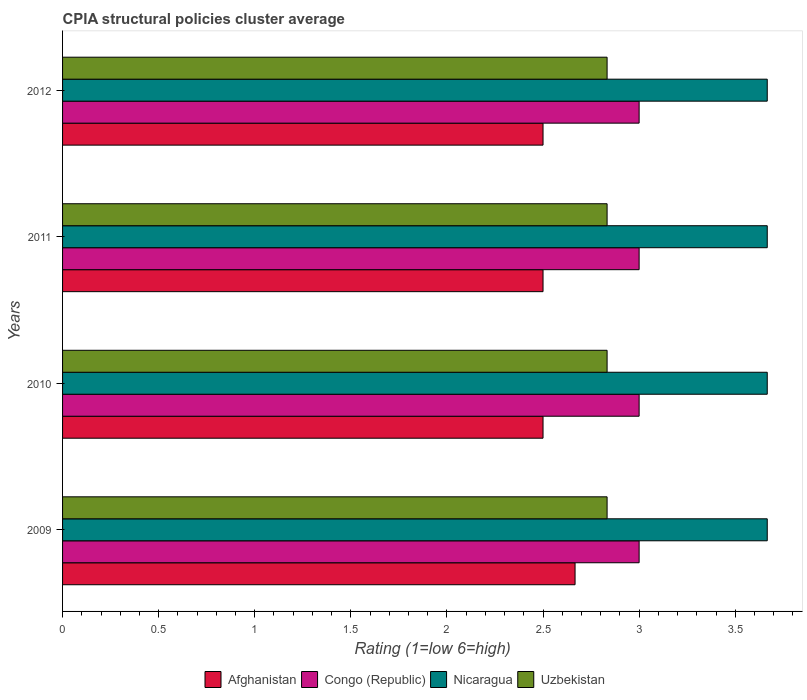How many different coloured bars are there?
Ensure brevity in your answer.  4. How many groups of bars are there?
Provide a succinct answer. 4. Are the number of bars on each tick of the Y-axis equal?
Provide a succinct answer. Yes. What is the CPIA rating in Uzbekistan in 2012?
Offer a very short reply. 2.83. Across all years, what is the maximum CPIA rating in Uzbekistan?
Give a very brief answer. 2.83. Across all years, what is the minimum CPIA rating in Congo (Republic)?
Give a very brief answer. 3. In which year was the CPIA rating in Afghanistan maximum?
Your answer should be very brief. 2009. What is the total CPIA rating in Uzbekistan in the graph?
Your response must be concise. 11.33. What is the difference between the CPIA rating in Nicaragua in 2010 and the CPIA rating in Congo (Republic) in 2012?
Provide a short and direct response. 0.67. What is the average CPIA rating in Afghanistan per year?
Your response must be concise. 2.54. In the year 2009, what is the difference between the CPIA rating in Afghanistan and CPIA rating in Congo (Republic)?
Offer a terse response. -0.33. What is the ratio of the CPIA rating in Nicaragua in 2009 to that in 2011?
Your response must be concise. 1. Is the CPIA rating in Congo (Republic) in 2010 less than that in 2011?
Your answer should be very brief. No. Is the difference between the CPIA rating in Afghanistan in 2010 and 2012 greater than the difference between the CPIA rating in Congo (Republic) in 2010 and 2012?
Keep it short and to the point. No. What is the difference between the highest and the second highest CPIA rating in Uzbekistan?
Provide a succinct answer. 0. In how many years, is the CPIA rating in Nicaragua greater than the average CPIA rating in Nicaragua taken over all years?
Give a very brief answer. 0. Is it the case that in every year, the sum of the CPIA rating in Afghanistan and CPIA rating in Congo (Republic) is greater than the sum of CPIA rating in Nicaragua and CPIA rating in Uzbekistan?
Offer a terse response. No. What does the 3rd bar from the top in 2009 represents?
Provide a short and direct response. Congo (Republic). What does the 4th bar from the bottom in 2011 represents?
Ensure brevity in your answer.  Uzbekistan. Is it the case that in every year, the sum of the CPIA rating in Nicaragua and CPIA rating in Afghanistan is greater than the CPIA rating in Uzbekistan?
Offer a very short reply. Yes. How many bars are there?
Your answer should be compact. 16. How many years are there in the graph?
Your response must be concise. 4. Are the values on the major ticks of X-axis written in scientific E-notation?
Ensure brevity in your answer.  No. Does the graph contain grids?
Provide a succinct answer. No. How many legend labels are there?
Your answer should be compact. 4. How are the legend labels stacked?
Offer a very short reply. Horizontal. What is the title of the graph?
Provide a short and direct response. CPIA structural policies cluster average. Does "Bolivia" appear as one of the legend labels in the graph?
Offer a very short reply. No. What is the label or title of the X-axis?
Ensure brevity in your answer.  Rating (1=low 6=high). What is the Rating (1=low 6=high) in Afghanistan in 2009?
Provide a short and direct response. 2.67. What is the Rating (1=low 6=high) of Congo (Republic) in 2009?
Offer a terse response. 3. What is the Rating (1=low 6=high) of Nicaragua in 2009?
Provide a short and direct response. 3.67. What is the Rating (1=low 6=high) of Uzbekistan in 2009?
Your response must be concise. 2.83. What is the Rating (1=low 6=high) in Afghanistan in 2010?
Offer a very short reply. 2.5. What is the Rating (1=low 6=high) in Nicaragua in 2010?
Give a very brief answer. 3.67. What is the Rating (1=low 6=high) of Uzbekistan in 2010?
Provide a short and direct response. 2.83. What is the Rating (1=low 6=high) of Nicaragua in 2011?
Your response must be concise. 3.67. What is the Rating (1=low 6=high) of Uzbekistan in 2011?
Your response must be concise. 2.83. What is the Rating (1=low 6=high) in Afghanistan in 2012?
Your response must be concise. 2.5. What is the Rating (1=low 6=high) in Congo (Republic) in 2012?
Offer a very short reply. 3. What is the Rating (1=low 6=high) in Nicaragua in 2012?
Offer a terse response. 3.67. What is the Rating (1=low 6=high) in Uzbekistan in 2012?
Provide a short and direct response. 2.83. Across all years, what is the maximum Rating (1=low 6=high) of Afghanistan?
Provide a short and direct response. 2.67. Across all years, what is the maximum Rating (1=low 6=high) of Nicaragua?
Offer a terse response. 3.67. Across all years, what is the maximum Rating (1=low 6=high) of Uzbekistan?
Offer a terse response. 2.83. Across all years, what is the minimum Rating (1=low 6=high) in Afghanistan?
Keep it short and to the point. 2.5. Across all years, what is the minimum Rating (1=low 6=high) of Congo (Republic)?
Give a very brief answer. 3. Across all years, what is the minimum Rating (1=low 6=high) in Nicaragua?
Provide a succinct answer. 3.67. Across all years, what is the minimum Rating (1=low 6=high) in Uzbekistan?
Your response must be concise. 2.83. What is the total Rating (1=low 6=high) in Afghanistan in the graph?
Offer a terse response. 10.17. What is the total Rating (1=low 6=high) in Nicaragua in the graph?
Give a very brief answer. 14.67. What is the total Rating (1=low 6=high) of Uzbekistan in the graph?
Your response must be concise. 11.33. What is the difference between the Rating (1=low 6=high) in Nicaragua in 2009 and that in 2010?
Make the answer very short. 0. What is the difference between the Rating (1=low 6=high) in Uzbekistan in 2009 and that in 2010?
Ensure brevity in your answer.  0. What is the difference between the Rating (1=low 6=high) in Afghanistan in 2009 and that in 2011?
Make the answer very short. 0.17. What is the difference between the Rating (1=low 6=high) in Nicaragua in 2009 and that in 2011?
Your answer should be compact. 0. What is the difference between the Rating (1=low 6=high) of Afghanistan in 2009 and that in 2012?
Your answer should be very brief. 0.17. What is the difference between the Rating (1=low 6=high) of Congo (Republic) in 2009 and that in 2012?
Provide a succinct answer. 0. What is the difference between the Rating (1=low 6=high) in Congo (Republic) in 2010 and that in 2011?
Offer a very short reply. 0. What is the difference between the Rating (1=low 6=high) in Nicaragua in 2010 and that in 2011?
Keep it short and to the point. 0. What is the difference between the Rating (1=low 6=high) of Afghanistan in 2010 and that in 2012?
Give a very brief answer. 0. What is the difference between the Rating (1=low 6=high) of Nicaragua in 2010 and that in 2012?
Make the answer very short. 0. What is the difference between the Rating (1=low 6=high) of Uzbekistan in 2010 and that in 2012?
Keep it short and to the point. 0. What is the difference between the Rating (1=low 6=high) in Uzbekistan in 2011 and that in 2012?
Your response must be concise. 0. What is the difference between the Rating (1=low 6=high) in Afghanistan in 2009 and the Rating (1=low 6=high) in Nicaragua in 2010?
Keep it short and to the point. -1. What is the difference between the Rating (1=low 6=high) of Congo (Republic) in 2009 and the Rating (1=low 6=high) of Uzbekistan in 2010?
Offer a very short reply. 0.17. What is the difference between the Rating (1=low 6=high) in Nicaragua in 2009 and the Rating (1=low 6=high) in Uzbekistan in 2010?
Offer a very short reply. 0.83. What is the difference between the Rating (1=low 6=high) of Afghanistan in 2009 and the Rating (1=low 6=high) of Congo (Republic) in 2011?
Provide a succinct answer. -0.33. What is the difference between the Rating (1=low 6=high) in Afghanistan in 2009 and the Rating (1=low 6=high) in Congo (Republic) in 2012?
Keep it short and to the point. -0.33. What is the difference between the Rating (1=low 6=high) of Afghanistan in 2009 and the Rating (1=low 6=high) of Uzbekistan in 2012?
Offer a very short reply. -0.17. What is the difference between the Rating (1=low 6=high) in Congo (Republic) in 2009 and the Rating (1=low 6=high) in Uzbekistan in 2012?
Your answer should be very brief. 0.17. What is the difference between the Rating (1=low 6=high) in Afghanistan in 2010 and the Rating (1=low 6=high) in Nicaragua in 2011?
Make the answer very short. -1.17. What is the difference between the Rating (1=low 6=high) of Afghanistan in 2010 and the Rating (1=low 6=high) of Uzbekistan in 2011?
Offer a terse response. -0.33. What is the difference between the Rating (1=low 6=high) in Congo (Republic) in 2010 and the Rating (1=low 6=high) in Uzbekistan in 2011?
Provide a succinct answer. 0.17. What is the difference between the Rating (1=low 6=high) of Afghanistan in 2010 and the Rating (1=low 6=high) of Congo (Republic) in 2012?
Ensure brevity in your answer.  -0.5. What is the difference between the Rating (1=low 6=high) in Afghanistan in 2010 and the Rating (1=low 6=high) in Nicaragua in 2012?
Give a very brief answer. -1.17. What is the difference between the Rating (1=low 6=high) in Congo (Republic) in 2010 and the Rating (1=low 6=high) in Uzbekistan in 2012?
Ensure brevity in your answer.  0.17. What is the difference between the Rating (1=low 6=high) of Nicaragua in 2010 and the Rating (1=low 6=high) of Uzbekistan in 2012?
Offer a very short reply. 0.83. What is the difference between the Rating (1=low 6=high) in Afghanistan in 2011 and the Rating (1=low 6=high) in Nicaragua in 2012?
Your answer should be very brief. -1.17. What is the average Rating (1=low 6=high) in Afghanistan per year?
Your response must be concise. 2.54. What is the average Rating (1=low 6=high) in Congo (Republic) per year?
Your answer should be very brief. 3. What is the average Rating (1=low 6=high) of Nicaragua per year?
Your answer should be compact. 3.67. What is the average Rating (1=low 6=high) in Uzbekistan per year?
Your answer should be compact. 2.83. In the year 2009, what is the difference between the Rating (1=low 6=high) in Afghanistan and Rating (1=low 6=high) in Nicaragua?
Give a very brief answer. -1. In the year 2010, what is the difference between the Rating (1=low 6=high) in Afghanistan and Rating (1=low 6=high) in Congo (Republic)?
Provide a short and direct response. -0.5. In the year 2010, what is the difference between the Rating (1=low 6=high) of Afghanistan and Rating (1=low 6=high) of Nicaragua?
Make the answer very short. -1.17. In the year 2010, what is the difference between the Rating (1=low 6=high) in Afghanistan and Rating (1=low 6=high) in Uzbekistan?
Your answer should be compact. -0.33. In the year 2010, what is the difference between the Rating (1=low 6=high) of Congo (Republic) and Rating (1=low 6=high) of Nicaragua?
Ensure brevity in your answer.  -0.67. In the year 2010, what is the difference between the Rating (1=low 6=high) in Congo (Republic) and Rating (1=low 6=high) in Uzbekistan?
Offer a very short reply. 0.17. In the year 2010, what is the difference between the Rating (1=low 6=high) of Nicaragua and Rating (1=low 6=high) of Uzbekistan?
Your response must be concise. 0.83. In the year 2011, what is the difference between the Rating (1=low 6=high) in Afghanistan and Rating (1=low 6=high) in Congo (Republic)?
Keep it short and to the point. -0.5. In the year 2011, what is the difference between the Rating (1=low 6=high) of Afghanistan and Rating (1=low 6=high) of Nicaragua?
Your response must be concise. -1.17. In the year 2011, what is the difference between the Rating (1=low 6=high) of Afghanistan and Rating (1=low 6=high) of Uzbekistan?
Make the answer very short. -0.33. In the year 2012, what is the difference between the Rating (1=low 6=high) of Afghanistan and Rating (1=low 6=high) of Congo (Republic)?
Give a very brief answer. -0.5. In the year 2012, what is the difference between the Rating (1=low 6=high) of Afghanistan and Rating (1=low 6=high) of Nicaragua?
Offer a very short reply. -1.17. In the year 2012, what is the difference between the Rating (1=low 6=high) in Afghanistan and Rating (1=low 6=high) in Uzbekistan?
Ensure brevity in your answer.  -0.33. In the year 2012, what is the difference between the Rating (1=low 6=high) in Congo (Republic) and Rating (1=low 6=high) in Uzbekistan?
Your answer should be compact. 0.17. In the year 2012, what is the difference between the Rating (1=low 6=high) of Nicaragua and Rating (1=low 6=high) of Uzbekistan?
Offer a terse response. 0.83. What is the ratio of the Rating (1=low 6=high) in Afghanistan in 2009 to that in 2010?
Your answer should be compact. 1.07. What is the ratio of the Rating (1=low 6=high) in Congo (Republic) in 2009 to that in 2010?
Make the answer very short. 1. What is the ratio of the Rating (1=low 6=high) in Nicaragua in 2009 to that in 2010?
Your answer should be compact. 1. What is the ratio of the Rating (1=low 6=high) of Afghanistan in 2009 to that in 2011?
Offer a very short reply. 1.07. What is the ratio of the Rating (1=low 6=high) in Congo (Republic) in 2009 to that in 2011?
Offer a terse response. 1. What is the ratio of the Rating (1=low 6=high) of Nicaragua in 2009 to that in 2011?
Offer a terse response. 1. What is the ratio of the Rating (1=low 6=high) of Afghanistan in 2009 to that in 2012?
Ensure brevity in your answer.  1.07. What is the ratio of the Rating (1=low 6=high) of Congo (Republic) in 2009 to that in 2012?
Your answer should be very brief. 1. What is the ratio of the Rating (1=low 6=high) in Afghanistan in 2010 to that in 2011?
Make the answer very short. 1. What is the ratio of the Rating (1=low 6=high) in Afghanistan in 2010 to that in 2012?
Make the answer very short. 1. What is the ratio of the Rating (1=low 6=high) in Nicaragua in 2011 to that in 2012?
Give a very brief answer. 1. What is the ratio of the Rating (1=low 6=high) of Uzbekistan in 2011 to that in 2012?
Provide a succinct answer. 1. What is the difference between the highest and the second highest Rating (1=low 6=high) in Congo (Republic)?
Make the answer very short. 0. What is the difference between the highest and the second highest Rating (1=low 6=high) in Nicaragua?
Provide a short and direct response. 0. What is the difference between the highest and the lowest Rating (1=low 6=high) in Afghanistan?
Make the answer very short. 0.17. What is the difference between the highest and the lowest Rating (1=low 6=high) in Congo (Republic)?
Provide a short and direct response. 0. What is the difference between the highest and the lowest Rating (1=low 6=high) in Nicaragua?
Offer a terse response. 0. 